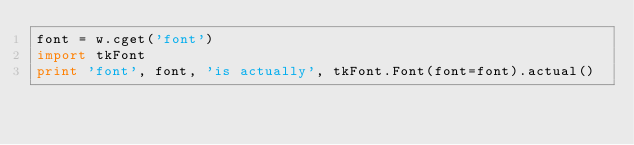<code> <loc_0><loc_0><loc_500><loc_500><_Python_>font = w.cget('font')
import tkFont
print 'font', font, 'is actually', tkFont.Font(font=font).actual()

</code> 